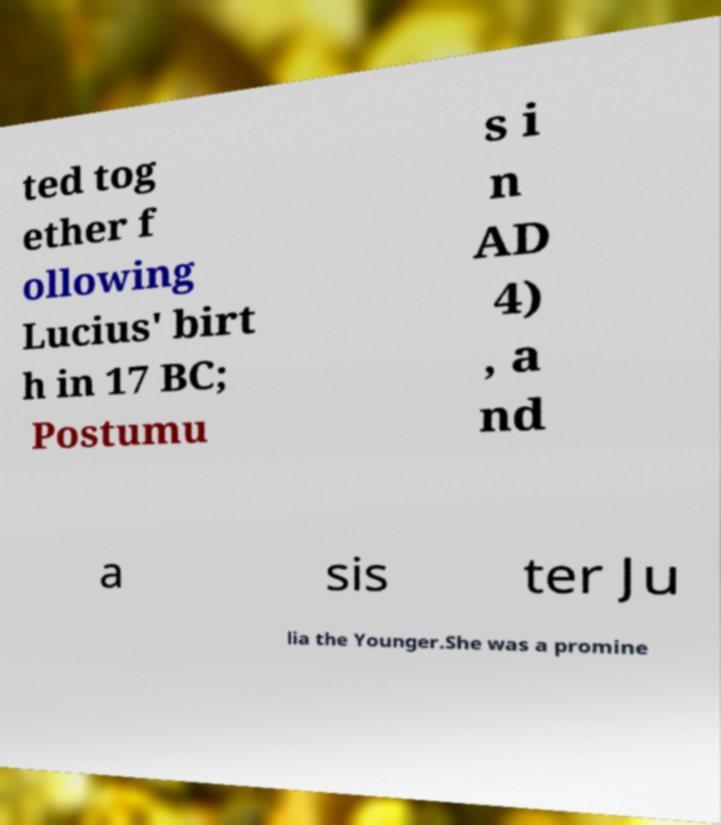There's text embedded in this image that I need extracted. Can you transcribe it verbatim? ted tog ether f ollowing Lucius' birt h in 17 BC; Postumu s i n AD 4) , a nd a sis ter Ju lia the Younger.She was a promine 